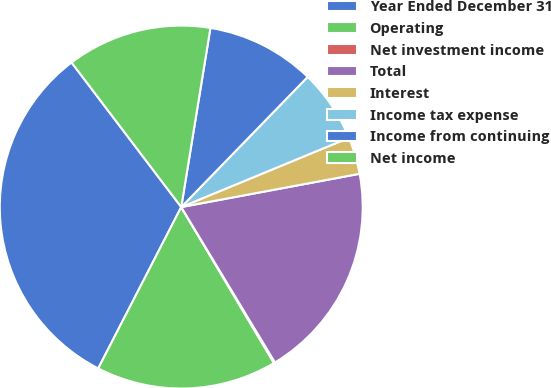Convert chart to OTSL. <chart><loc_0><loc_0><loc_500><loc_500><pie_chart><fcel>Year Ended December 31<fcel>Operating<fcel>Net investment income<fcel>Total<fcel>Interest<fcel>Income tax expense<fcel>Income from continuing<fcel>Net income<nl><fcel>32.11%<fcel>16.1%<fcel>0.1%<fcel>19.3%<fcel>3.3%<fcel>6.5%<fcel>9.7%<fcel>12.9%<nl></chart> 